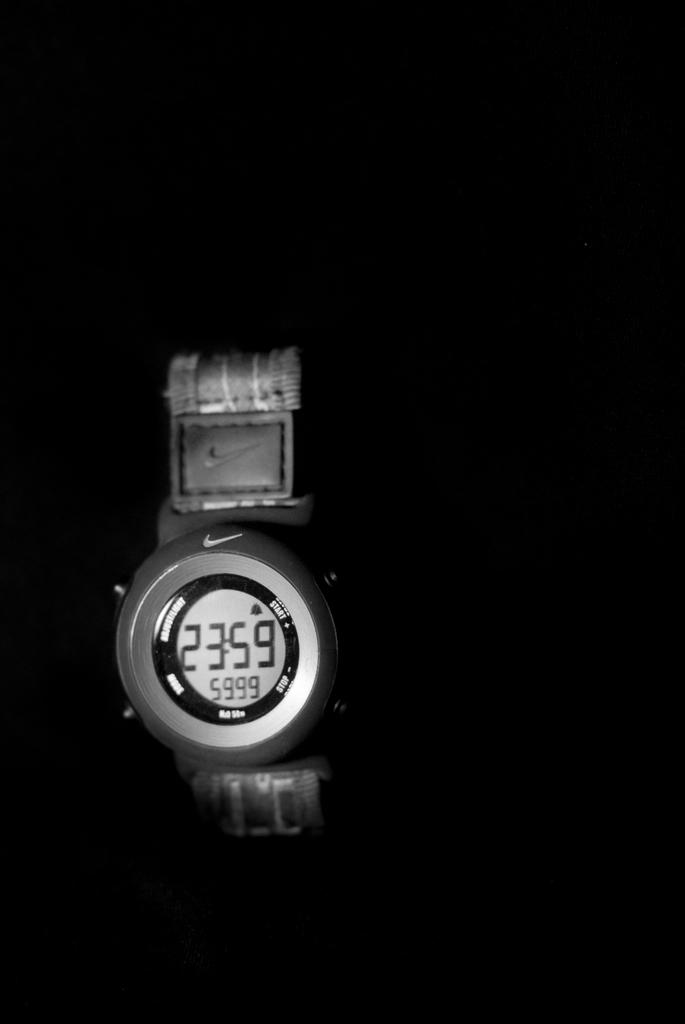<image>
Describe the image concisely. A watch showing the time as 23:59 on a dark background 